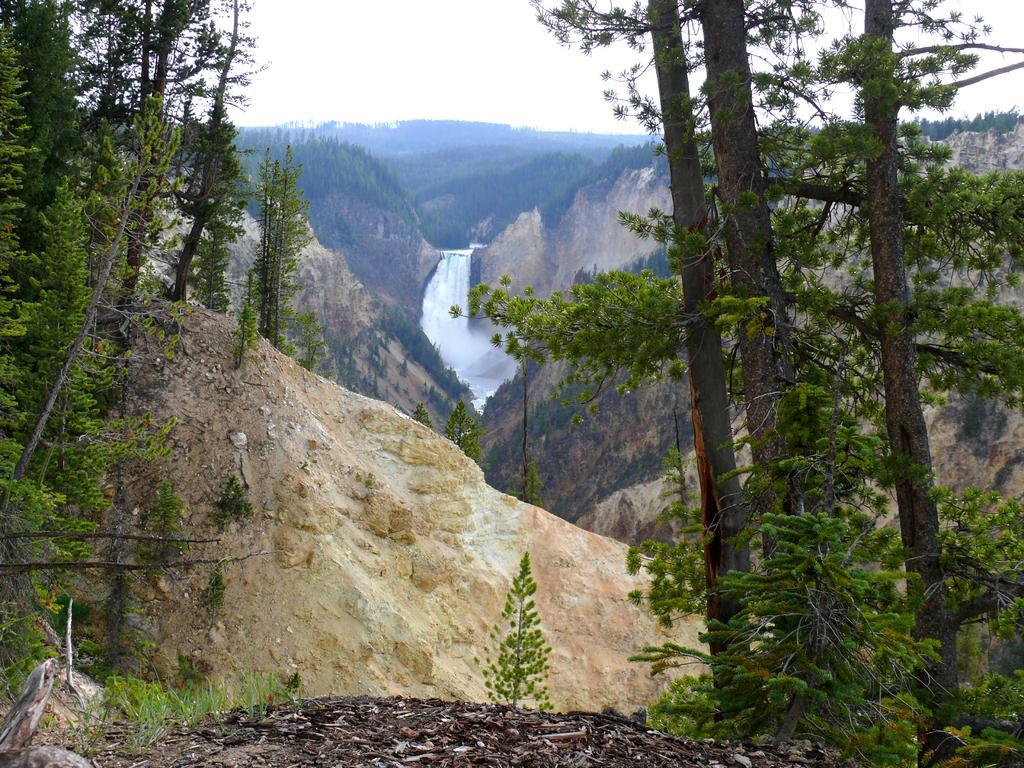Describe this image in one or two sentences. In this picture I can observe some trees. In the middle of the picture there is a waterfall. I can observe hills in this picture. In the background there is sky. 